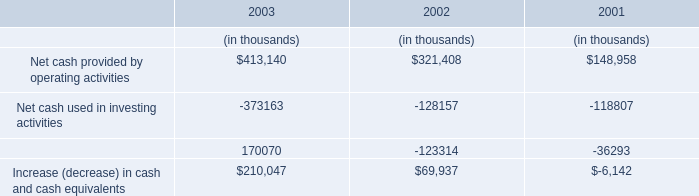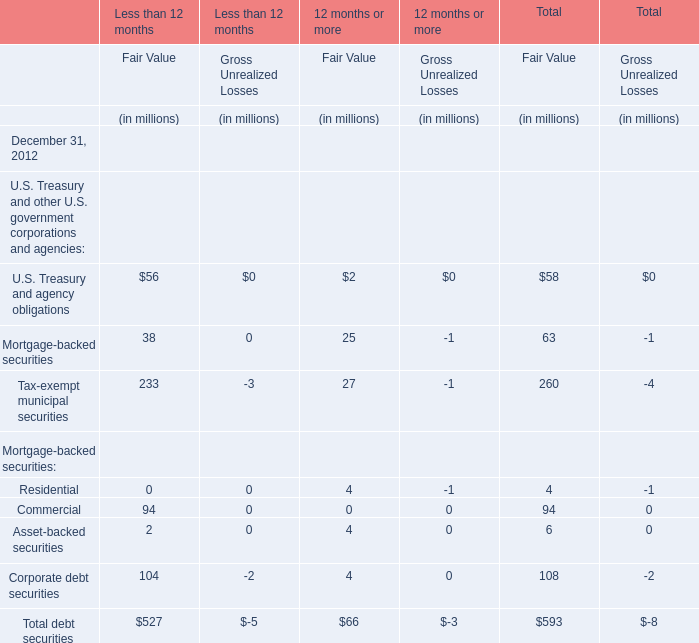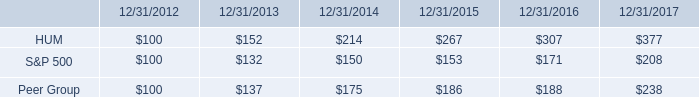what is the increase observed in the return of the second year of the investment for peer group? 
Computations: ((175 / 137) - 1)
Answer: 0.27737. 